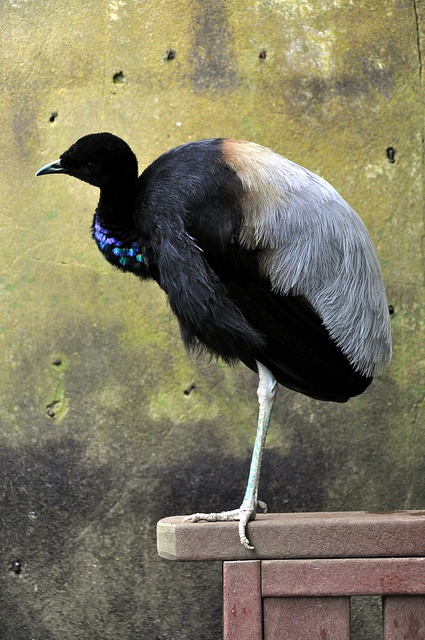Describe the objects in this image and their specific colors. I can see bird in tan, black, gray, darkgray, and lightgray tones and bench in tan, gray, darkgray, and black tones in this image. 